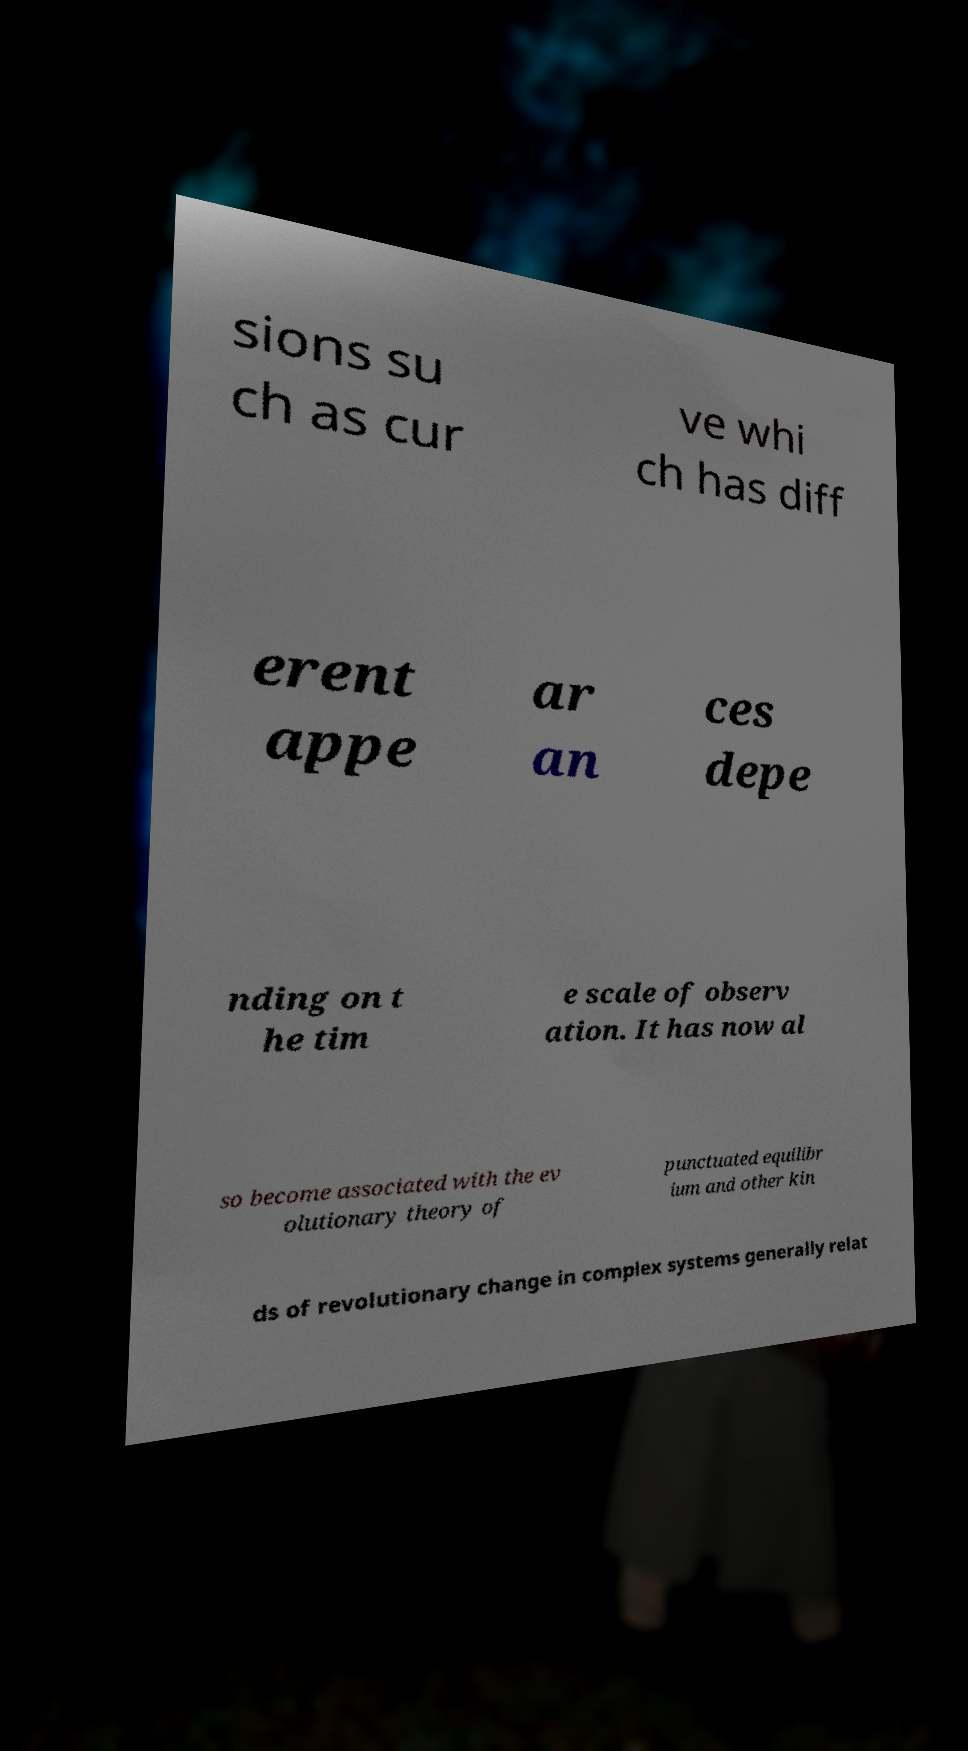Could you extract and type out the text from this image? sions su ch as cur ve whi ch has diff erent appe ar an ces depe nding on t he tim e scale of observ ation. It has now al so become associated with the ev olutionary theory of punctuated equilibr ium and other kin ds of revolutionary change in complex systems generally relat 